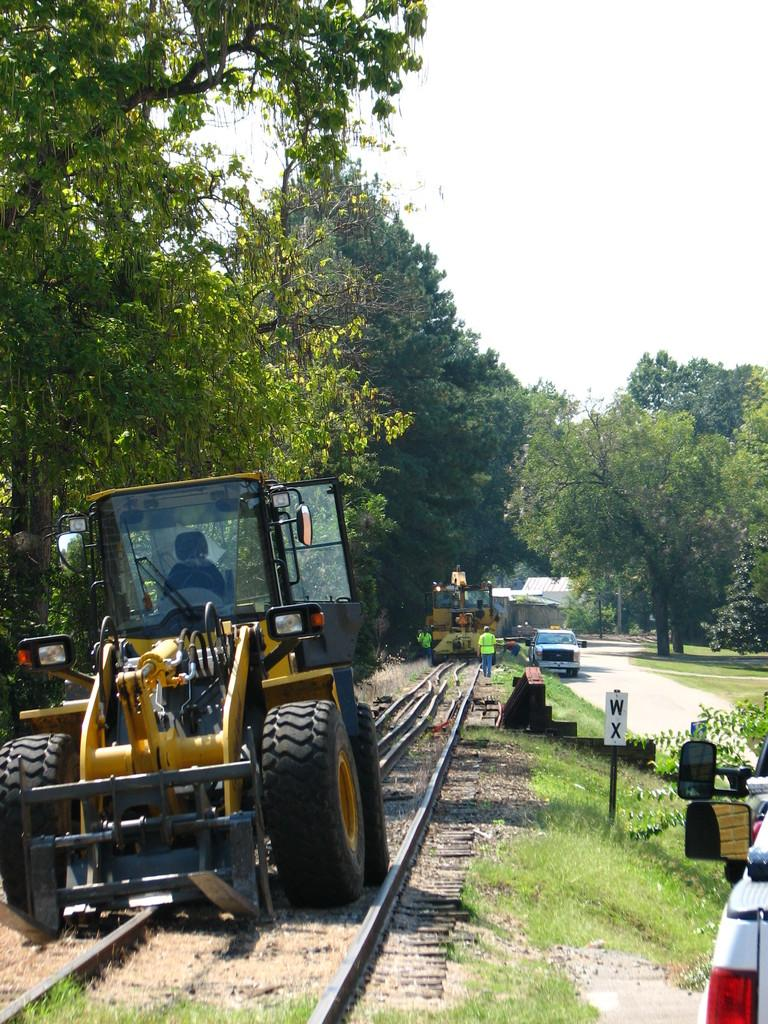What types of vehicles can be seen in the image? There are personal vehicles in the image. What is the board used for in the image? The purpose of the board in the image is not specified, but it is present. What is the rod used for in the image? The purpose of the rod in the image is not specified, but it is present. What type of vegetation is visible in the image? Trees and grass are visible in the image. What is the train track used for in the image? The train track is used for trains to travel on, although no train is visible in the image. What part of the natural environment is visible in the image? The sky is visible in the image. What type of structure is present in the image? There is a house in the image. What type of pathway is present in the image? There is a road in the image. What objects are present in the image? There are objects in the image, including vehicles, a board, a rod, trees, grass, a train track, and a house. What is the position of the vehicle in relation to the road in the image? A vehicle is on the road in the image. What type of blood is visible on the vehicle in the image? There is no blood visible on the vehicle in the image. What type of tail is attached to the house in the image? There is no tail attached to the house in the image. What type of music can be heard coming from the objects in the image? There is no indication of music in the image, as it only contains visual elements. 